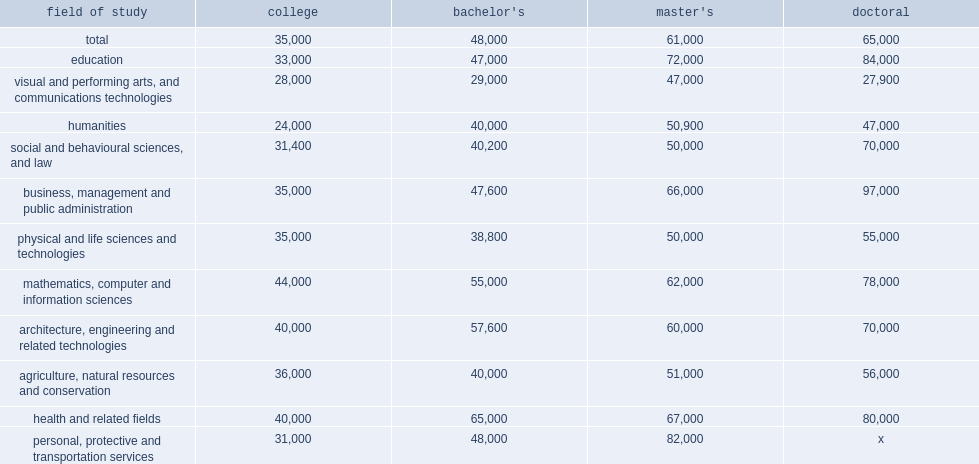How many dollars did college graduates earn in employment income? 35000.0. How many dollars did bachelor graduates earn in employment income? 48000.0. How many dollars did master graduates earn in employment income? 61000.0. How many dollars did doctoral graduates earn in employment income? 65000.0. I'm looking to parse the entire table for insights. Could you assist me with that? {'header': ['field of study', 'college', "bachelor's", "master's", 'doctoral'], 'rows': [['total', '35,000', '48,000', '61,000', '65,000'], ['education', '33,000', '47,000', '72,000', '84,000'], ['visual and performing arts, and communications technologies', '28,000', '29,000', '47,000', '27,900'], ['humanities', '24,000', '40,000', '50,900', '47,000'], ['social and behavioural sciences, and law', '31,400', '40,200', '50,000', '70,000'], ['business, management and public administration', '35,000', '47,600', '66,000', '97,000'], ['physical and life sciences and technologies', '35,000', '38,800', '50,000', '55,000'], ['mathematics, computer and information sciences', '44,000', '55,000', '62,000', '78,000'], ['architecture, engineering and related technologies', '40,000', '57,600', '60,000', '70,000'], ['agriculture, natural resources and conservation', '36,000', '40,000', '51,000', '56,000'], ['health and related fields', '40,000', '65,000', '67,000', '80,000'], ['personal, protective and transportation services', '31,000', '48,000', '82,000', 'x']]} 